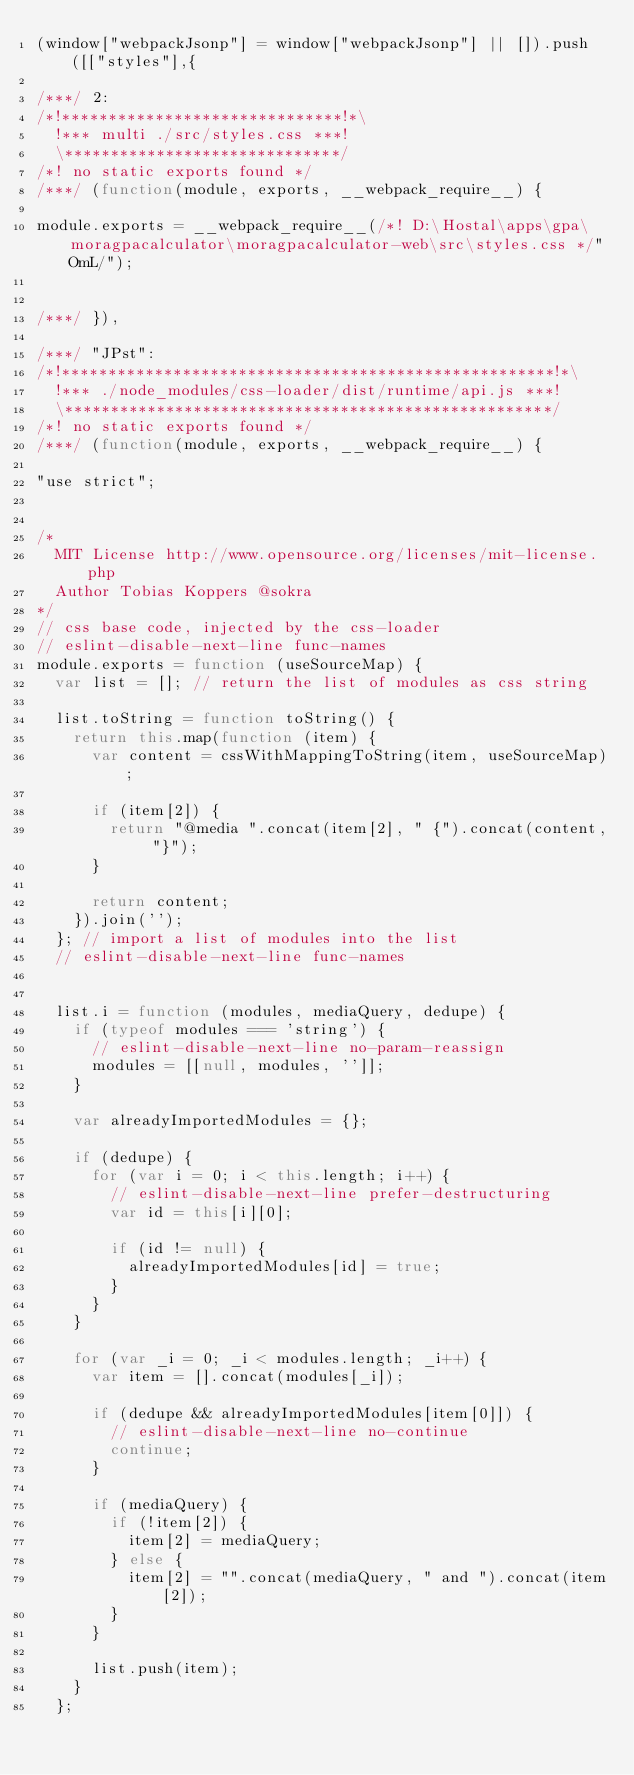Convert code to text. <code><loc_0><loc_0><loc_500><loc_500><_JavaScript_>(window["webpackJsonp"] = window["webpackJsonp"] || []).push([["styles"],{

/***/ 2:
/*!******************************!*\
  !*** multi ./src/styles.css ***!
  \******************************/
/*! no static exports found */
/***/ (function(module, exports, __webpack_require__) {

module.exports = __webpack_require__(/*! D:\Hostal\apps\gpa\moragpacalculator\moragpacalculator-web\src\styles.css */"OmL/");


/***/ }),

/***/ "JPst":
/*!*****************************************************!*\
  !*** ./node_modules/css-loader/dist/runtime/api.js ***!
  \*****************************************************/
/*! no static exports found */
/***/ (function(module, exports, __webpack_require__) {

"use strict";


/*
  MIT License http://www.opensource.org/licenses/mit-license.php
  Author Tobias Koppers @sokra
*/
// css base code, injected by the css-loader
// eslint-disable-next-line func-names
module.exports = function (useSourceMap) {
  var list = []; // return the list of modules as css string

  list.toString = function toString() {
    return this.map(function (item) {
      var content = cssWithMappingToString(item, useSourceMap);

      if (item[2]) {
        return "@media ".concat(item[2], " {").concat(content, "}");
      }

      return content;
    }).join('');
  }; // import a list of modules into the list
  // eslint-disable-next-line func-names


  list.i = function (modules, mediaQuery, dedupe) {
    if (typeof modules === 'string') {
      // eslint-disable-next-line no-param-reassign
      modules = [[null, modules, '']];
    }

    var alreadyImportedModules = {};

    if (dedupe) {
      for (var i = 0; i < this.length; i++) {
        // eslint-disable-next-line prefer-destructuring
        var id = this[i][0];

        if (id != null) {
          alreadyImportedModules[id] = true;
        }
      }
    }

    for (var _i = 0; _i < modules.length; _i++) {
      var item = [].concat(modules[_i]);

      if (dedupe && alreadyImportedModules[item[0]]) {
        // eslint-disable-next-line no-continue
        continue;
      }

      if (mediaQuery) {
        if (!item[2]) {
          item[2] = mediaQuery;
        } else {
          item[2] = "".concat(mediaQuery, " and ").concat(item[2]);
        }
      }

      list.push(item);
    }
  };
</code> 